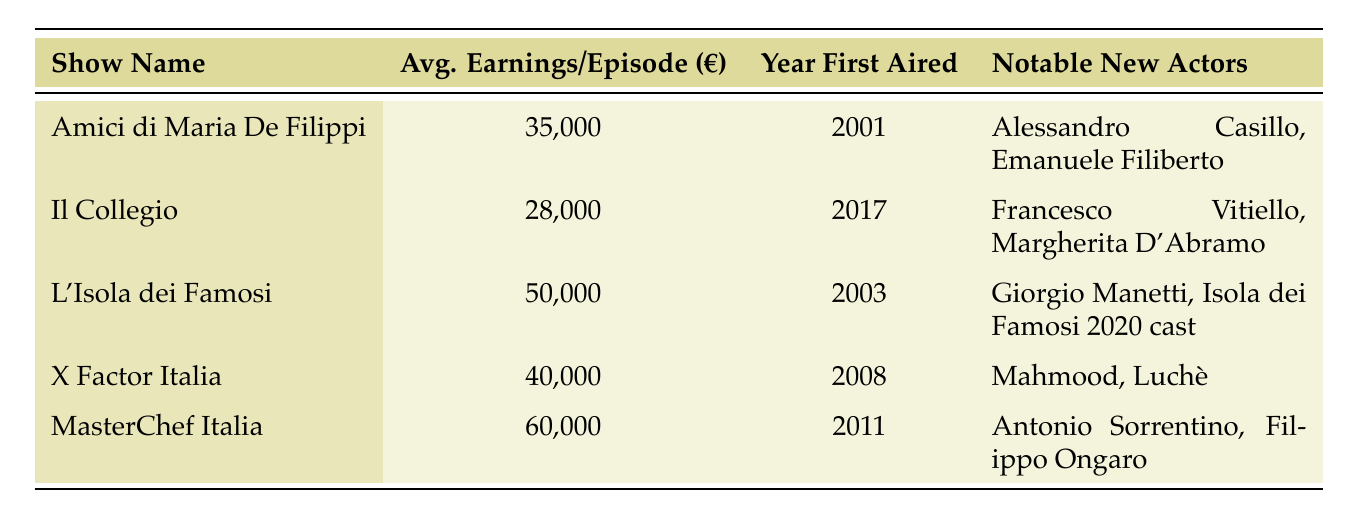What is the average earnings per episode of "MasterChef Italia"? According to the table, "MasterChef Italia" has average earnings listed as €60,000 per episode.
Answer: 60,000 Which show aired first, "Il Collegio" or "X Factor Italia"? The table shows that "Il Collegio" first aired in 2017 and "X Factor Italia" first aired in 2008, meaning "X Factor Italia" aired first.
Answer: X Factor Italia How much more does "L'Isola dei Famosi" earn per episode compared to "Il Collegio"? To find the difference, we take the earnings of "L'Isola dei Famosi" (€50,000) and subtract the earnings of "Il Collegio" (€28,000), resulting in €22,000.
Answer: 22,000 Which show has the largest average earnings per episode, and who are its notable new actors? The table indicates that "MasterChef Italia" has the highest earnings at €60,000 per episode, with notable new actors being Antonio Sorrentino and Filippo Ongaro.
Answer: MasterChef Italia; Antonio Sorrentino, Filippo Ongaro What is the total average earnings per episode for the five listed shows? We sum the average earnings: 35,000 (Amici) + 28,000 (Il Collegio) + 50,000 (L'Isola dei Famosi) + 40,000 (X Factor Italia) + 60,000 (MasterChef Italia) = 213,000. To find the total average, we divide by 5, resulting in 42,600.
Answer: 42,600 Did "Alessandro Casillo" appear in a show that has average earnings greater than €40,000? "Alessandro Casillo" is noted in "Amici di Maria De Filippi," which has earnings of €35,000, less than €40,000. Thus, the answer is no.
Answer: No How many shows were first aired before 2010? The shows first aired before 2010 include "Amici di Maria De Filippi" (2001), "L'Isola dei Famosi" (2003), and "X Factor Italia" (2008), totaling three shows.
Answer: 3 Is there a show with notable new actors from outside music or reality television? "MasterChef Italia" features notable new actors like Antonio Sorrentino and Filippo Ongaro, who are not primarily known for music or reality television, answering yes to the question.
Answer: Yes What is the average earnings difference between the highest and lowest-earning show? The highest-earning show is "MasterChef Italia" with €60,000 and the lowest is "Il Collegio" with €28,000. The difference is €60,000 - €28,000 = €32,000.
Answer: 32,000 